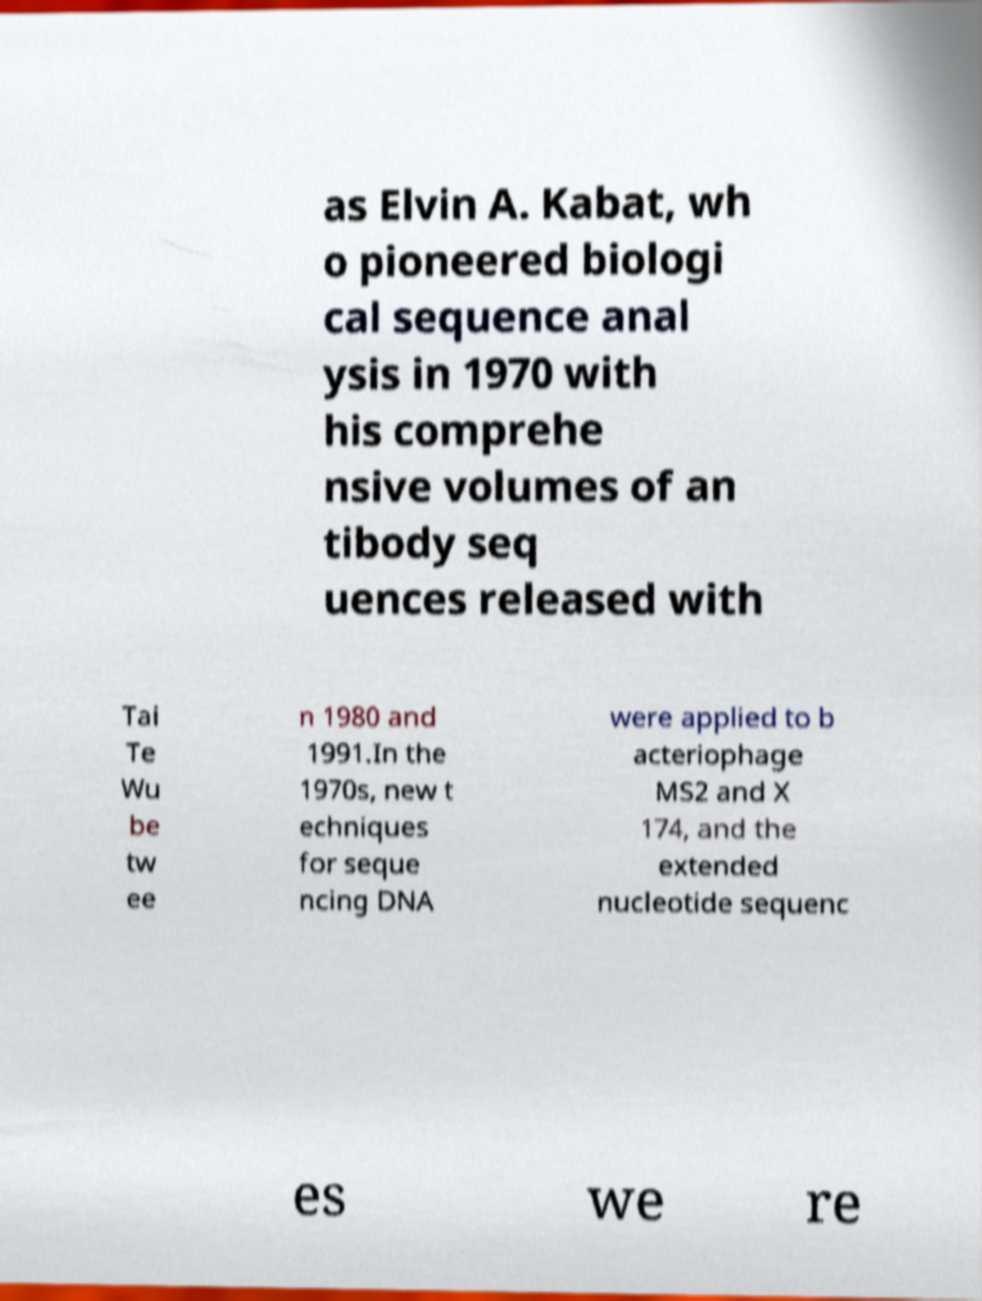Could you extract and type out the text from this image? as Elvin A. Kabat, wh o pioneered biologi cal sequence anal ysis in 1970 with his comprehe nsive volumes of an tibody seq uences released with Tai Te Wu be tw ee n 1980 and 1991.In the 1970s, new t echniques for seque ncing DNA were applied to b acteriophage MS2 and X 174, and the extended nucleotide sequenc es we re 